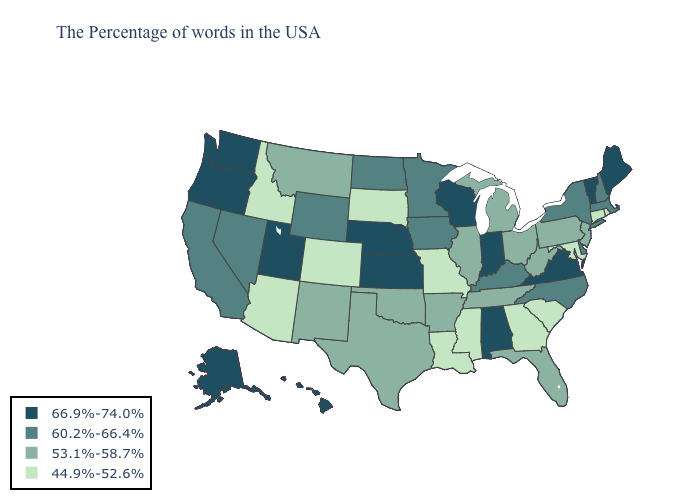What is the value of Louisiana?
Write a very short answer. 44.9%-52.6%. Does South Carolina have a higher value than California?
Write a very short answer. No. Does the first symbol in the legend represent the smallest category?
Answer briefly. No. Which states have the lowest value in the South?
Give a very brief answer. Maryland, South Carolina, Georgia, Mississippi, Louisiana. Which states have the lowest value in the MidWest?
Concise answer only. Missouri, South Dakota. Is the legend a continuous bar?
Keep it brief. No. Name the states that have a value in the range 66.9%-74.0%?
Write a very short answer. Maine, Vermont, Virginia, Indiana, Alabama, Wisconsin, Kansas, Nebraska, Utah, Washington, Oregon, Alaska, Hawaii. What is the highest value in states that border Washington?
Answer briefly. 66.9%-74.0%. What is the highest value in states that border Maine?
Be succinct. 60.2%-66.4%. What is the value of Ohio?
Quick response, please. 53.1%-58.7%. Does Alaska have the same value as Virginia?
Be succinct. Yes. Does the first symbol in the legend represent the smallest category?
Answer briefly. No. Among the states that border Washington , does Oregon have the highest value?
Write a very short answer. Yes. Does Colorado have the same value as Delaware?
Be succinct. No. What is the lowest value in the USA?
Keep it brief. 44.9%-52.6%. 